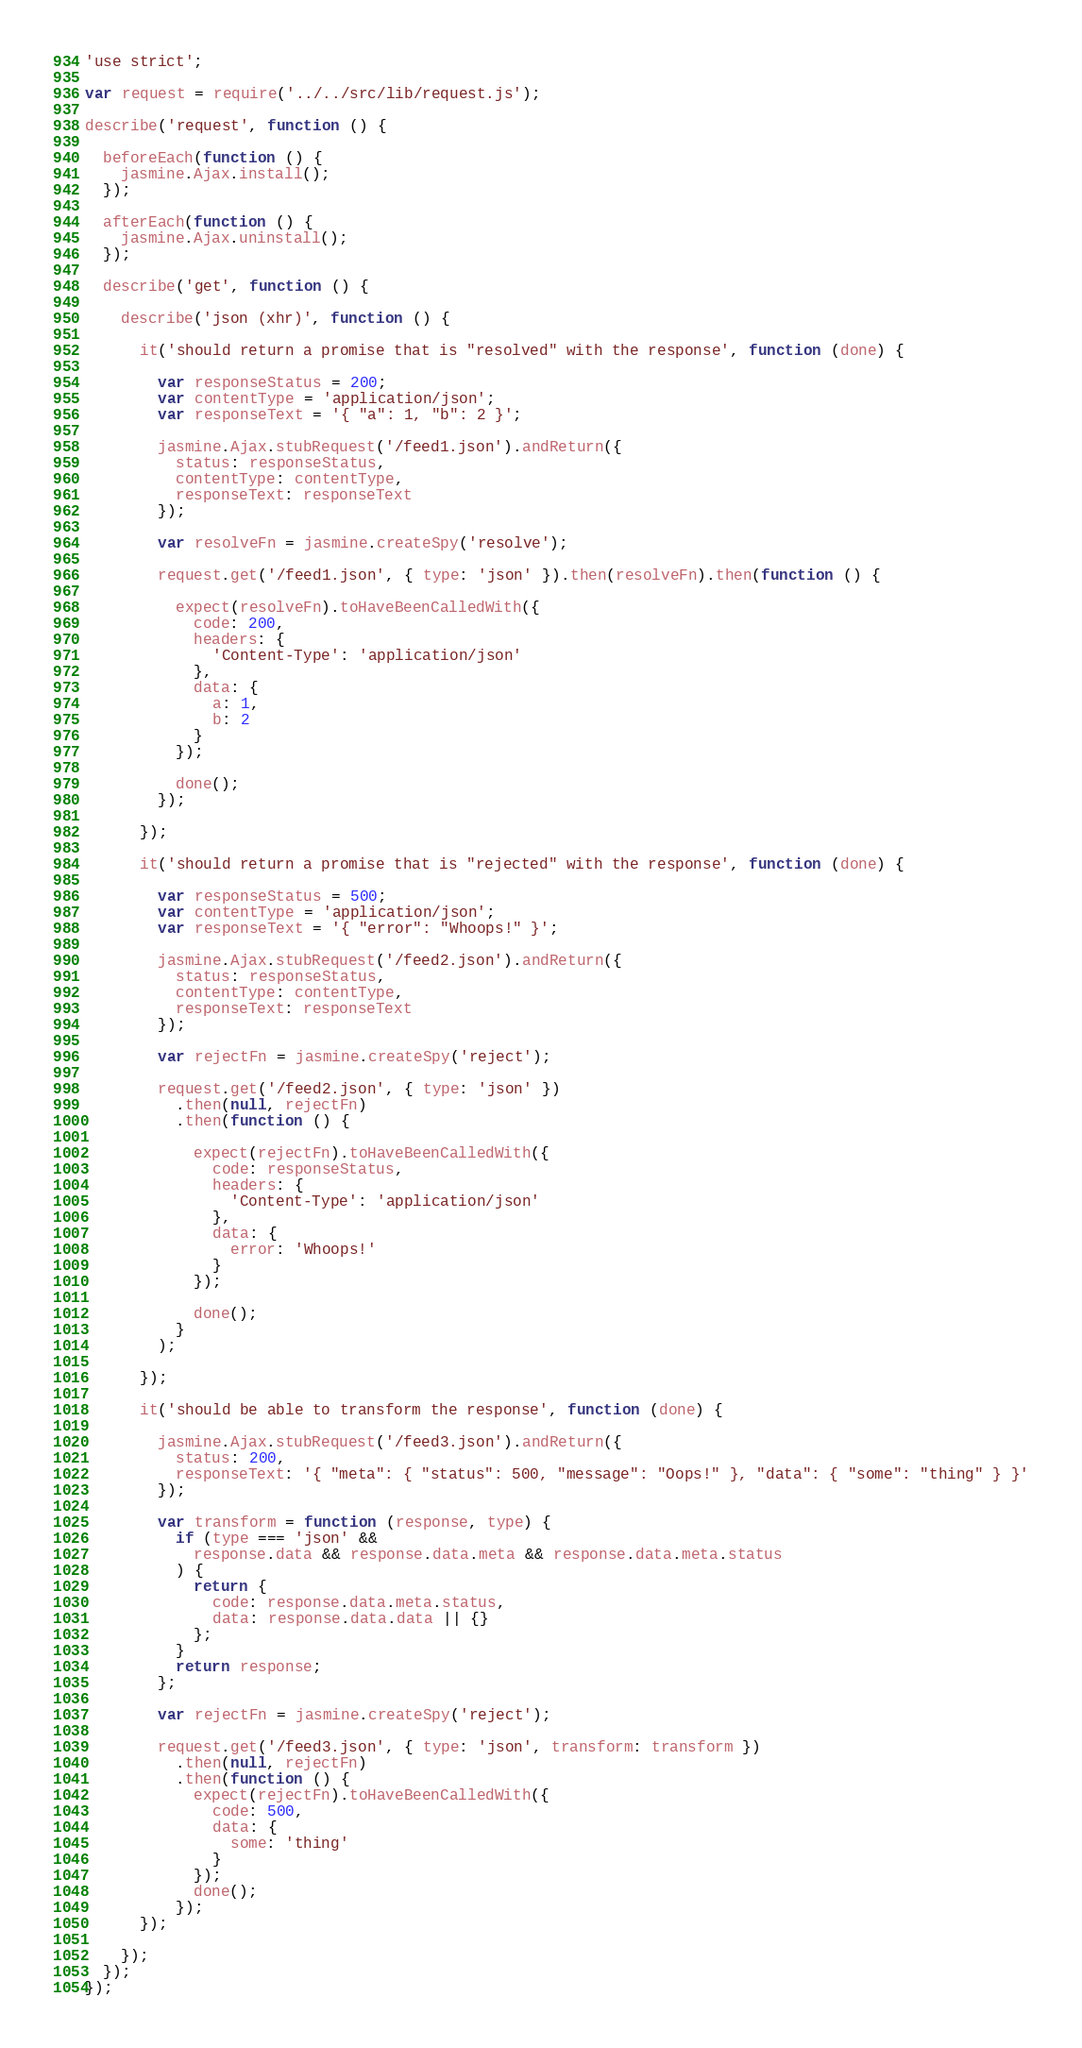Convert code to text. <code><loc_0><loc_0><loc_500><loc_500><_JavaScript_>'use strict';

var request = require('../../src/lib/request.js');

describe('request', function () {

  beforeEach(function () {
    jasmine.Ajax.install();
  });
  
  afterEach(function () {
    jasmine.Ajax.uninstall();
  });

  describe('get', function () {

    describe('json (xhr)', function () {

      it('should return a promise that is "resolved" with the response', function (done) {
        
        var responseStatus = 200;
        var contentType = 'application/json';
        var responseText = '{ "a": 1, "b": 2 }';
        
        jasmine.Ajax.stubRequest('/feed1.json').andReturn({
          status: responseStatus,
          contentType: contentType,
          responseText: responseText
        });
        
        var resolveFn = jasmine.createSpy('resolve');
        
        request.get('/feed1.json', { type: 'json' }).then(resolveFn).then(function () {
          
          expect(resolveFn).toHaveBeenCalledWith({
            code: 200,
            headers: {
              'Content-Type': 'application/json'
            },
            data: {
              a: 1,
              b: 2
            }
          });
          
          done();
        });
        
      });
      
      it('should return a promise that is "rejected" with the response', function (done) {
        
        var responseStatus = 500;
        var contentType = 'application/json';
        var responseText = '{ "error": "Whoops!" }';

        jasmine.Ajax.stubRequest('/feed2.json').andReturn({
          status: responseStatus,
          contentType: contentType,
          responseText: responseText
        });
        
        var rejectFn = jasmine.createSpy('reject');
        
        request.get('/feed2.json', { type: 'json' })
          .then(null, rejectFn)
          .then(function () {
            
            expect(rejectFn).toHaveBeenCalledWith({
              code: responseStatus,
              headers: {
                'Content-Type': 'application/json'
              },
              data: {
                error: 'Whoops!'
              }
            });
            
            done();
          }
        );
        
      });
      
      it('should be able to transform the response', function (done) {
        
        jasmine.Ajax.stubRequest('/feed3.json').andReturn({
          status: 200,
          responseText: '{ "meta": { "status": 500, "message": "Oops!" }, "data": { "some": "thing" } }'
        });
        
        var transform = function (response, type) {
          if (type === 'json' &&
            response.data && response.data.meta && response.data.meta.status
          ) {
            return {
              code: response.data.meta.status,
              data: response.data.data || {}
            };
          }
          return response;
        };
        
        var rejectFn = jasmine.createSpy('reject');
        
        request.get('/feed3.json', { type: 'json', transform: transform })
          .then(null, rejectFn)
          .then(function () {
            expect(rejectFn).toHaveBeenCalledWith({
              code: 500,
              data: {
                some: 'thing'
              }
            });
            done();
          });
      });
      
    });
  });
});
</code> 